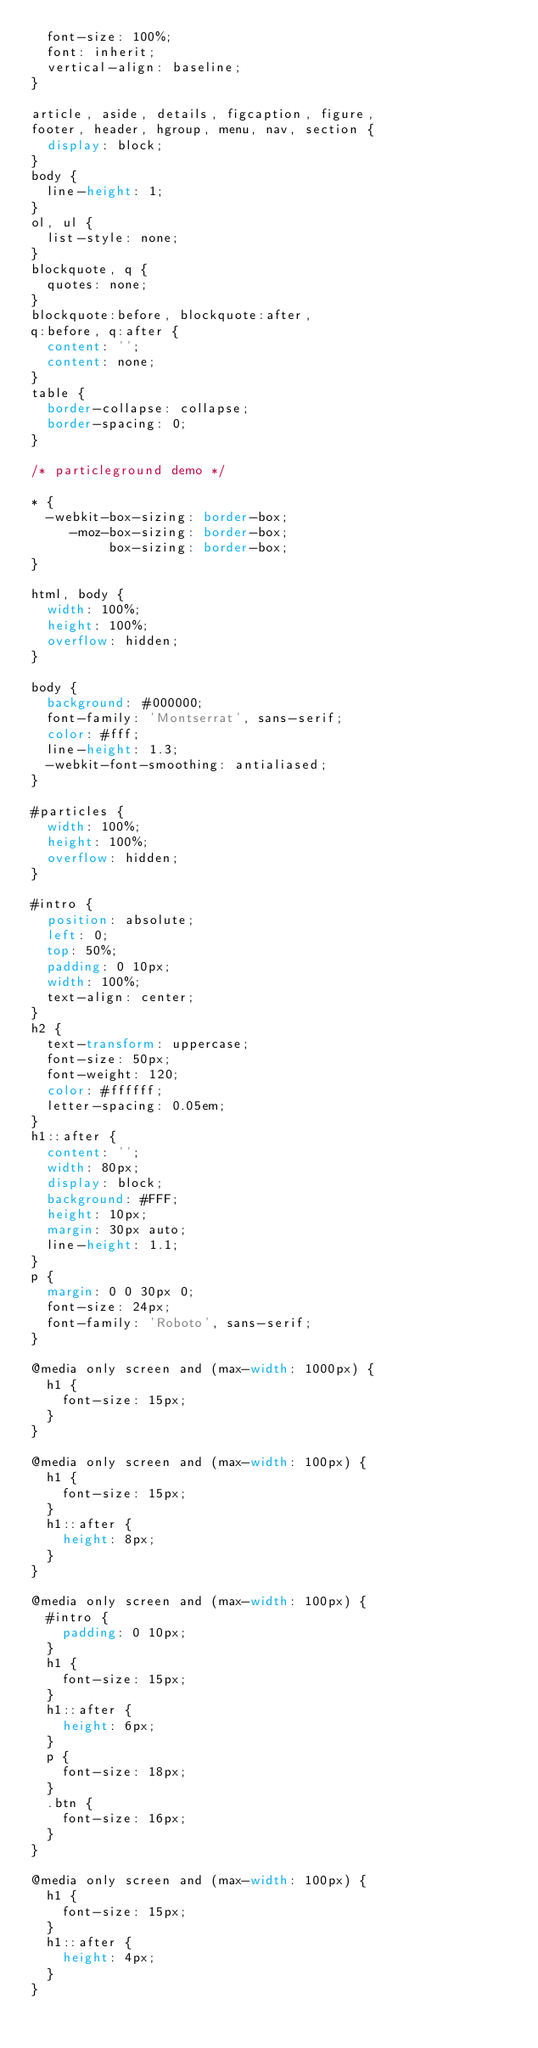<code> <loc_0><loc_0><loc_500><loc_500><_CSS_>  font-size: 100%;
  font: inherit;
  vertical-align: baseline;  
}

article, aside, details, figcaption, figure,
footer, header, hgroup, menu, nav, section {
  display: block;
}
body {
  line-height: 1;
}
ol, ul {
  list-style: none;
}
blockquote, q {
  quotes: none;
}
blockquote:before, blockquote:after,
q:before, q:after {
  content: '';
  content: none;
}
table {
  border-collapse: collapse;
  border-spacing: 0;
}

/* particleground demo */

* {
  -webkit-box-sizing: border-box;
     -moz-box-sizing: border-box;
          box-sizing: border-box;
}

html, body {
  width: 100%;
  height: 100%;
  overflow: hidden;
}

body {
  background: #000000;
  font-family: 'Montserrat', sans-serif;
  color: #fff;
  line-height: 1.3;
  -webkit-font-smoothing: antialiased;
}

#particles {
  width: 100%;
  height: 100%;
  overflow: hidden;
}

#intro {
  position: absolute;
  left: 0;
  top: 50%;
  padding: 0 10px;
  width: 100%;
  text-align: center;
}
h2 {
  text-transform: uppercase;
  font-size: 50px;
  font-weight: 120;
  color: #ffffff;
  letter-spacing: 0.05em;
}
h1::after {
  content: '';
  width: 80px;
  display: block;
  background: #FFF;
  height: 10px;
  margin: 30px auto;
  line-height: 1.1;
}
p {
  margin: 0 0 30px 0;
  font-size: 24px;
  font-family: 'Roboto', sans-serif;
}

@media only screen and (max-width: 1000px) {
  h1 {
    font-size: 15px;
  }
}

@media only screen and (max-width: 100px) {
  h1 {
    font-size: 15px;
  }
  h1::after {
    height: 8px;
  }
}

@media only screen and (max-width: 100px) {
  #intro {
    padding: 0 10px;
  }
  h1 {
    font-size: 15px;
  }
  h1::after {
    height: 6px;
  }
  p {
    font-size: 18px;
  }
  .btn {
    font-size: 16px;
  }
}

@media only screen and (max-width: 100px) {
  h1 {
    font-size: 15px;
  }
  h1::after {
    height: 4px;
  }
}
</code> 